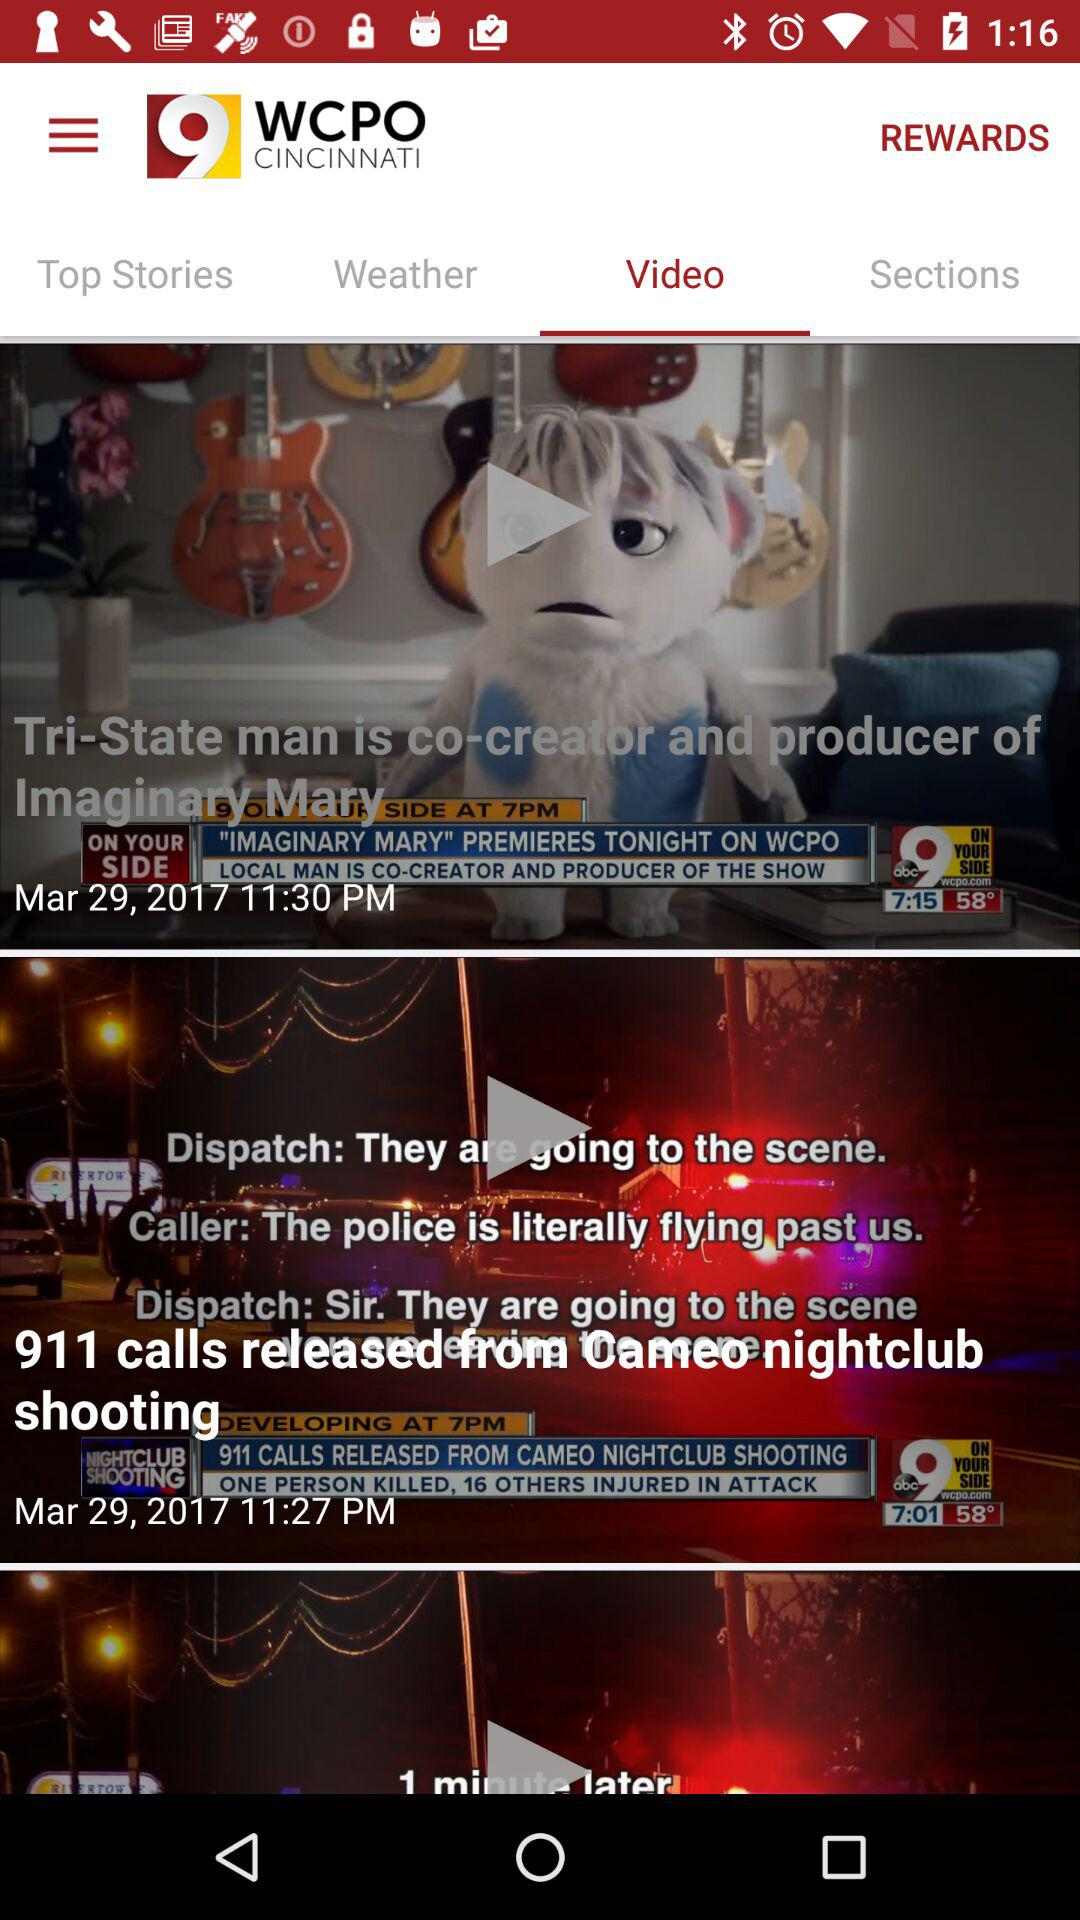What is the release date of imaginary Mary?
When the provided information is insufficient, respond with <no answer>. <no answer> 